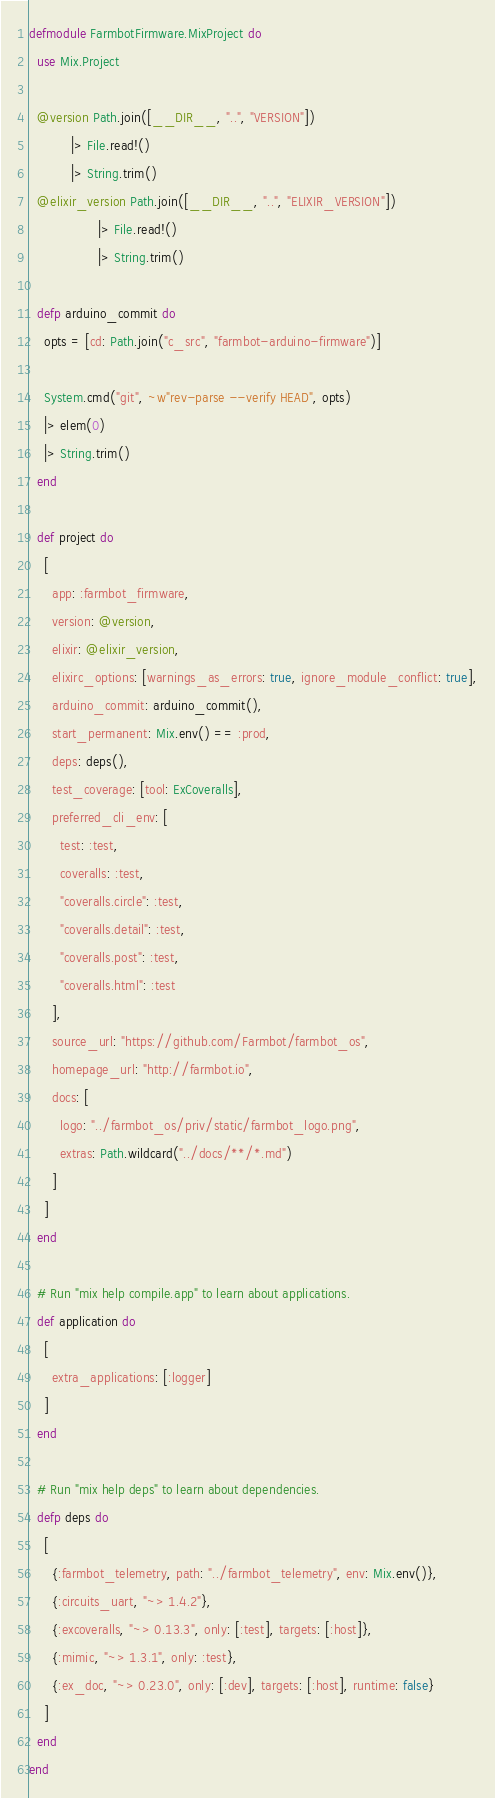<code> <loc_0><loc_0><loc_500><loc_500><_Elixir_>defmodule FarmbotFirmware.MixProject do
  use Mix.Project

  @version Path.join([__DIR__, "..", "VERSION"])
           |> File.read!()
           |> String.trim()
  @elixir_version Path.join([__DIR__, "..", "ELIXIR_VERSION"])
                  |> File.read!()
                  |> String.trim()

  defp arduino_commit do
    opts = [cd: Path.join("c_src", "farmbot-arduino-firmware")]

    System.cmd("git", ~w"rev-parse --verify HEAD", opts)
    |> elem(0)
    |> String.trim()
  end

  def project do
    [
      app: :farmbot_firmware,
      version: @version,
      elixir: @elixir_version,
      elixirc_options: [warnings_as_errors: true, ignore_module_conflict: true],
      arduino_commit: arduino_commit(),
      start_permanent: Mix.env() == :prod,
      deps: deps(),
      test_coverage: [tool: ExCoveralls],
      preferred_cli_env: [
        test: :test,
        coveralls: :test,
        "coveralls.circle": :test,
        "coveralls.detail": :test,
        "coveralls.post": :test,
        "coveralls.html": :test
      ],
      source_url: "https://github.com/Farmbot/farmbot_os",
      homepage_url: "http://farmbot.io",
      docs: [
        logo: "../farmbot_os/priv/static/farmbot_logo.png",
        extras: Path.wildcard("../docs/**/*.md")
      ]
    ]
  end

  # Run "mix help compile.app" to learn about applications.
  def application do
    [
      extra_applications: [:logger]
    ]
  end

  # Run "mix help deps" to learn about dependencies.
  defp deps do
    [
      {:farmbot_telemetry, path: "../farmbot_telemetry", env: Mix.env()},
      {:circuits_uart, "~> 1.4.2"},
      {:excoveralls, "~> 0.13.3", only: [:test], targets: [:host]},
      {:mimic, "~> 1.3.1", only: :test},
      {:ex_doc, "~> 0.23.0", only: [:dev], targets: [:host], runtime: false}
    ]
  end
end
</code> 